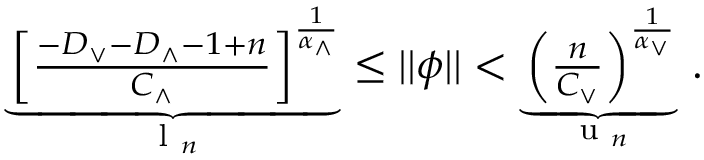<formula> <loc_0><loc_0><loc_500><loc_500>\begin{array} { r } { \underbrace { \left [ \frac { - D _ { \vee } - D _ { \wedge } - 1 + n } { C _ { \wedge } } \right ] ^ { \frac { 1 } { \alpha _ { \wedge } } } } _ { l _ { n } } \leq | | \phi | | < \underbrace { \left ( \frac { n } { C _ { \vee } } \right ) ^ { \frac { 1 } { \alpha _ { \vee } } } } _ { u _ { n } } \, . } \end{array}</formula> 